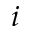Convert formula to latex. <formula><loc_0><loc_0><loc_500><loc_500>i</formula> 